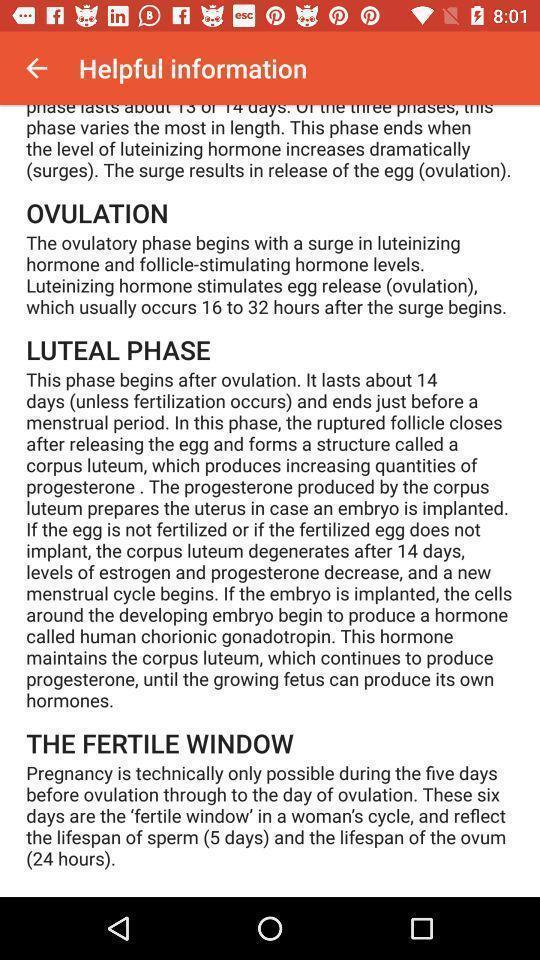Give me a narrative description of this picture. Page showing helpful information. 